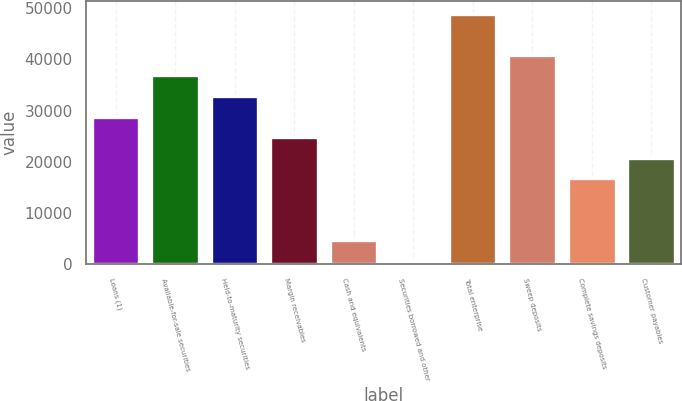Convert chart to OTSL. <chart><loc_0><loc_0><loc_500><loc_500><bar_chart><fcel>Loans (1)<fcel>Available-for-sale securities<fcel>Held-to-maturity securities<fcel>Margin receivables<fcel>Cash and equivalents<fcel>Securities borrowed and other<fcel>Total enterprise<fcel>Sweep deposits<fcel>Complete savings deposits<fcel>Customer payables<nl><fcel>28821.5<fcel>36868.5<fcel>32845<fcel>24798<fcel>4680.5<fcel>657<fcel>48939<fcel>40892<fcel>16751<fcel>20774.5<nl></chart> 